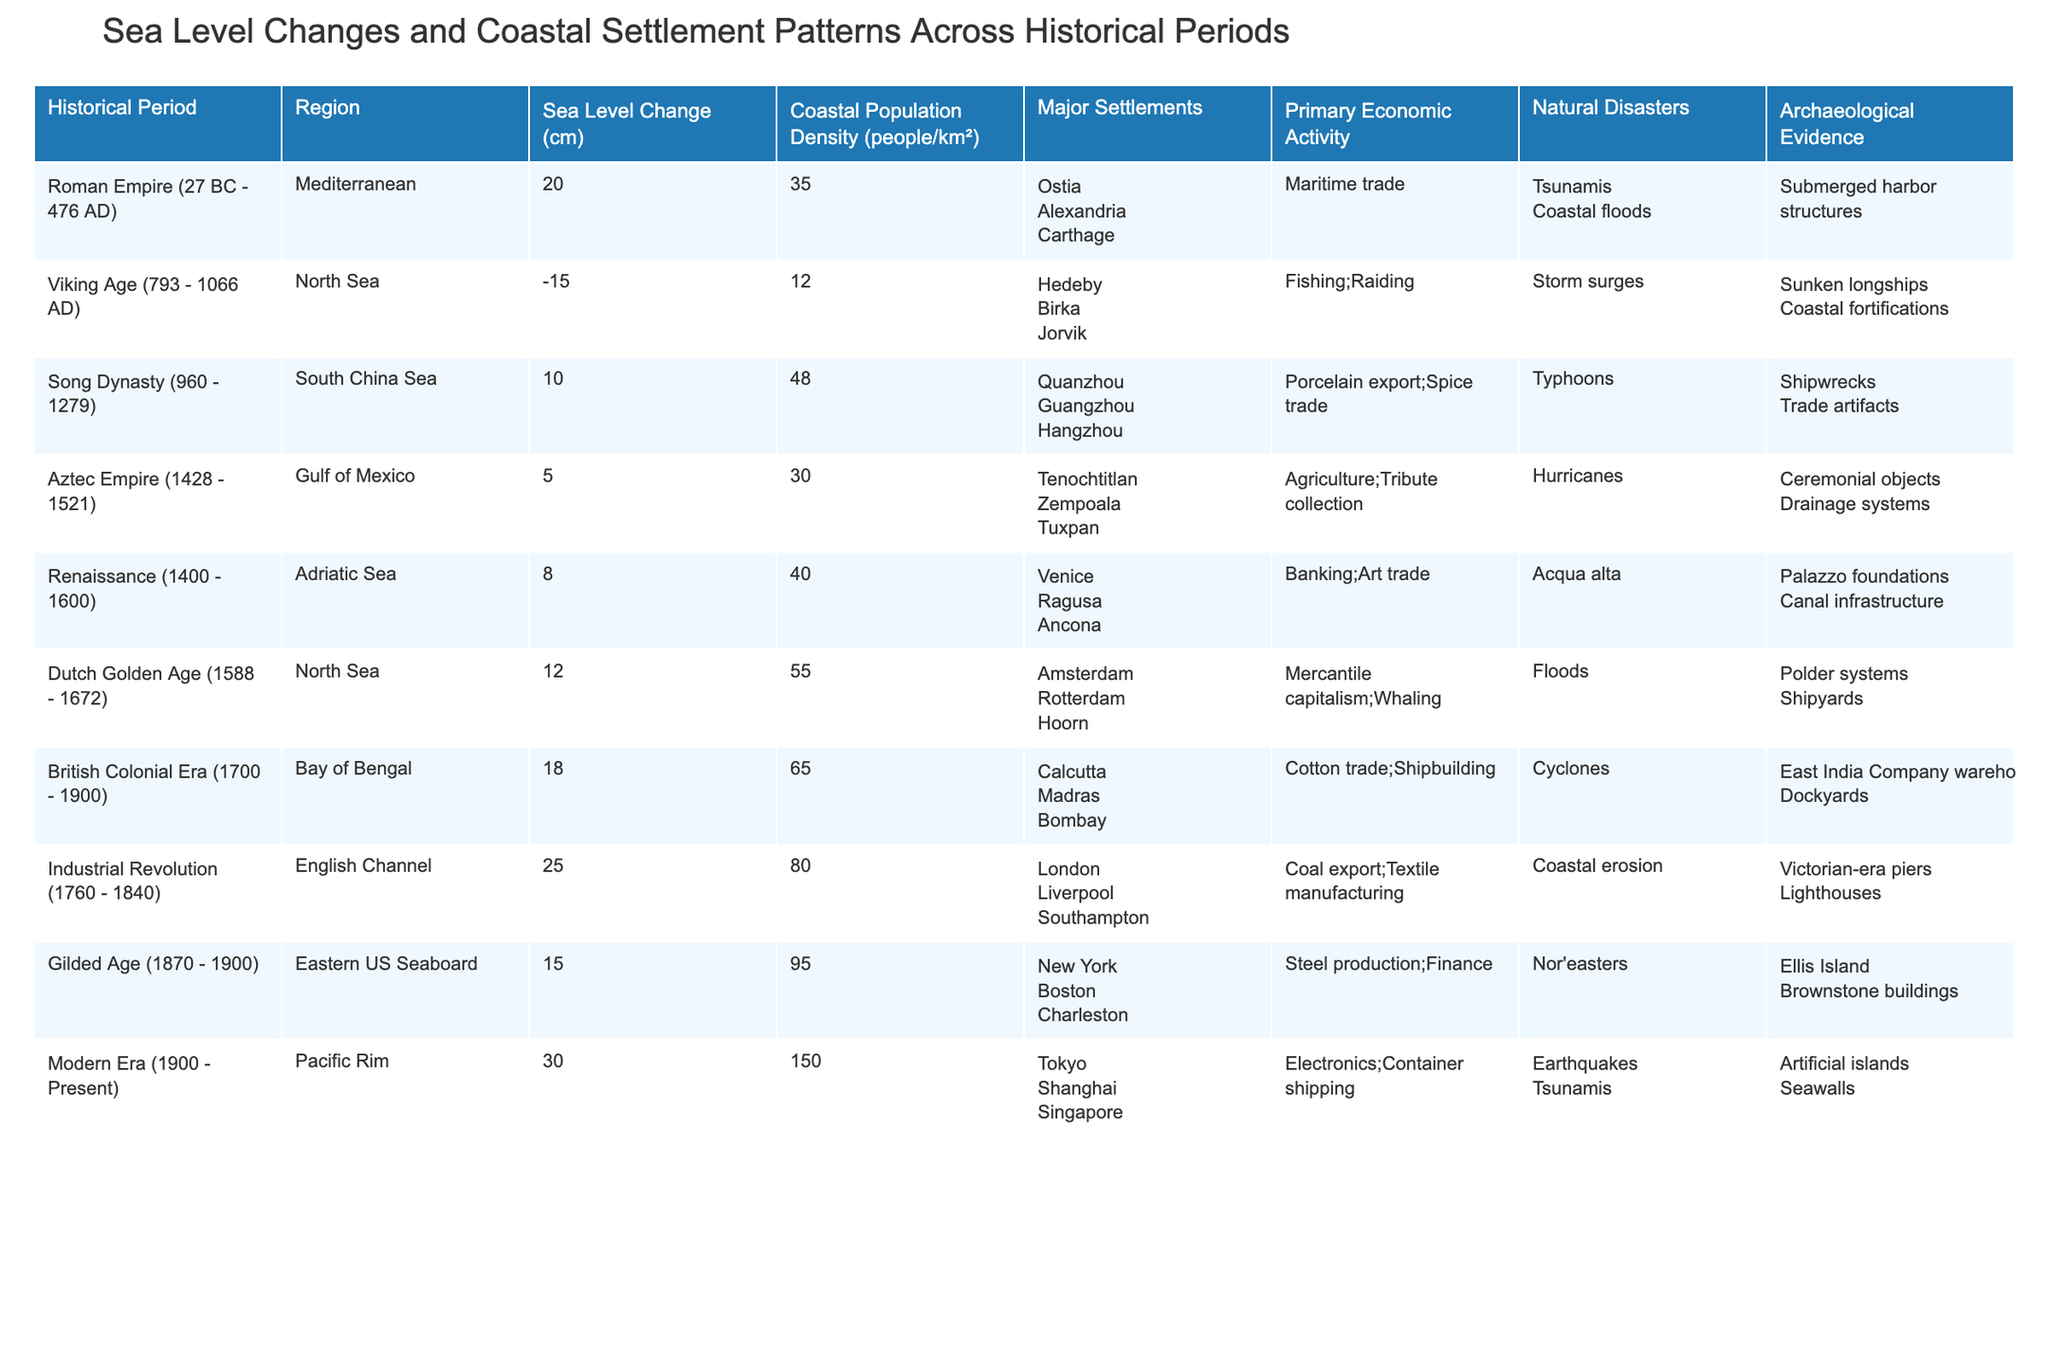What was the sea level change during the Industrial Revolution? The sea level change during the Industrial Revolution (1760 - 1840) is listed in the table as +25 cm.
Answer: +25 cm Which historical period had the highest coastal population density? By examining the coastal population density values in the table, the Modern Era (1900 - Present) has the highest density at 150 people/km².
Answer: 150 people/km² Did the Viking Age experience a rise or fall in sea level? The sea level change during the Viking Age (793 - 1066 AD) is documented as -15 cm, indicating a fall in sea level.
Answer: Fall What is the difference in sea level change between the British Colonial Era and the Dutch Golden Age? The sea level change for the British Colonial Era is +18 cm while for the Dutch Golden Age it is +12 cm. The difference is 18 - 12 = 6 cm.
Answer: 6 cm Which two historical periods had similar sea level changes and what were those values? The sea level changes for the Aztec Empire (+5 cm) and the Dutch Golden Age (+12 cm) are not similar. However, both the Renaissance and Aztec Empire had values close to +8 cm and +5 cm respectively.
Answer: +5 cm and +12 cm How many major settlements are mentioned for the Gilded Age? The Gilded Age (1870 - 1900) lists three major settlements: New York, Boston, and Charleston.
Answer: 3 What was the primary economic activity of the Song Dynasty? According to the table, the primary economic activity of the Song Dynasty (960 - 1279) involved porcelain export and spice trade.
Answer: Porcelain export; Spice trade Which period recorded the least amount of archaeological evidence? The Viking Age (793 - 1066 AD) recorded the least archaeological evidence, including sunken longships and coastal fortifications, compared to other periods.
Answer: Viking Age What is the average sea level change of the periods listed? To calculate the average, sum the sea level changes: 20 + (-15) + 10 + 5 + 8 + 12 + 18 + 25 + 15 + 30 =  143 cm, then divide by 10 periods to get an average of 14.3 cm.
Answer: 14.3 cm Did the Mediterranean region have a higher population density than the Gulf of Mexico during the Roman Empire? The Mediterranean region's coastal population density was 35 people/km², while the Gulf of Mexico's was 30 people/km², indicating the Mediterranean had a higher density.
Answer: Yes 